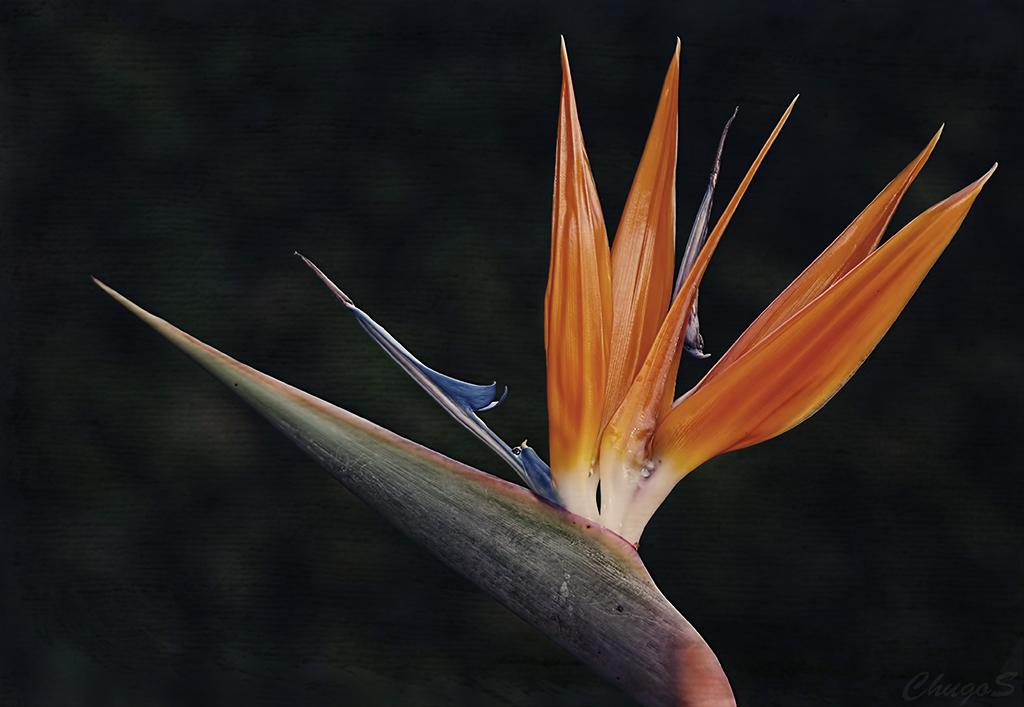What is the main subject of the image? The main subject of the image is a flower. Can you describe the color of the flower? The flower has orange and blue colors. What type of crack is visible in the image? There is no crack present in the image; it features a flower with orange and blue colors. What kind of toothbrush is being used to learn in the image? There is no toothbrush or learning activity depicted in the image; it only shows a flower. 